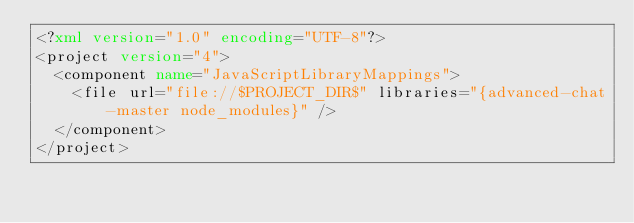Convert code to text. <code><loc_0><loc_0><loc_500><loc_500><_XML_><?xml version="1.0" encoding="UTF-8"?>
<project version="4">
  <component name="JavaScriptLibraryMappings">
    <file url="file://$PROJECT_DIR$" libraries="{advanced-chat-master node_modules}" />
  </component>
</project></code> 